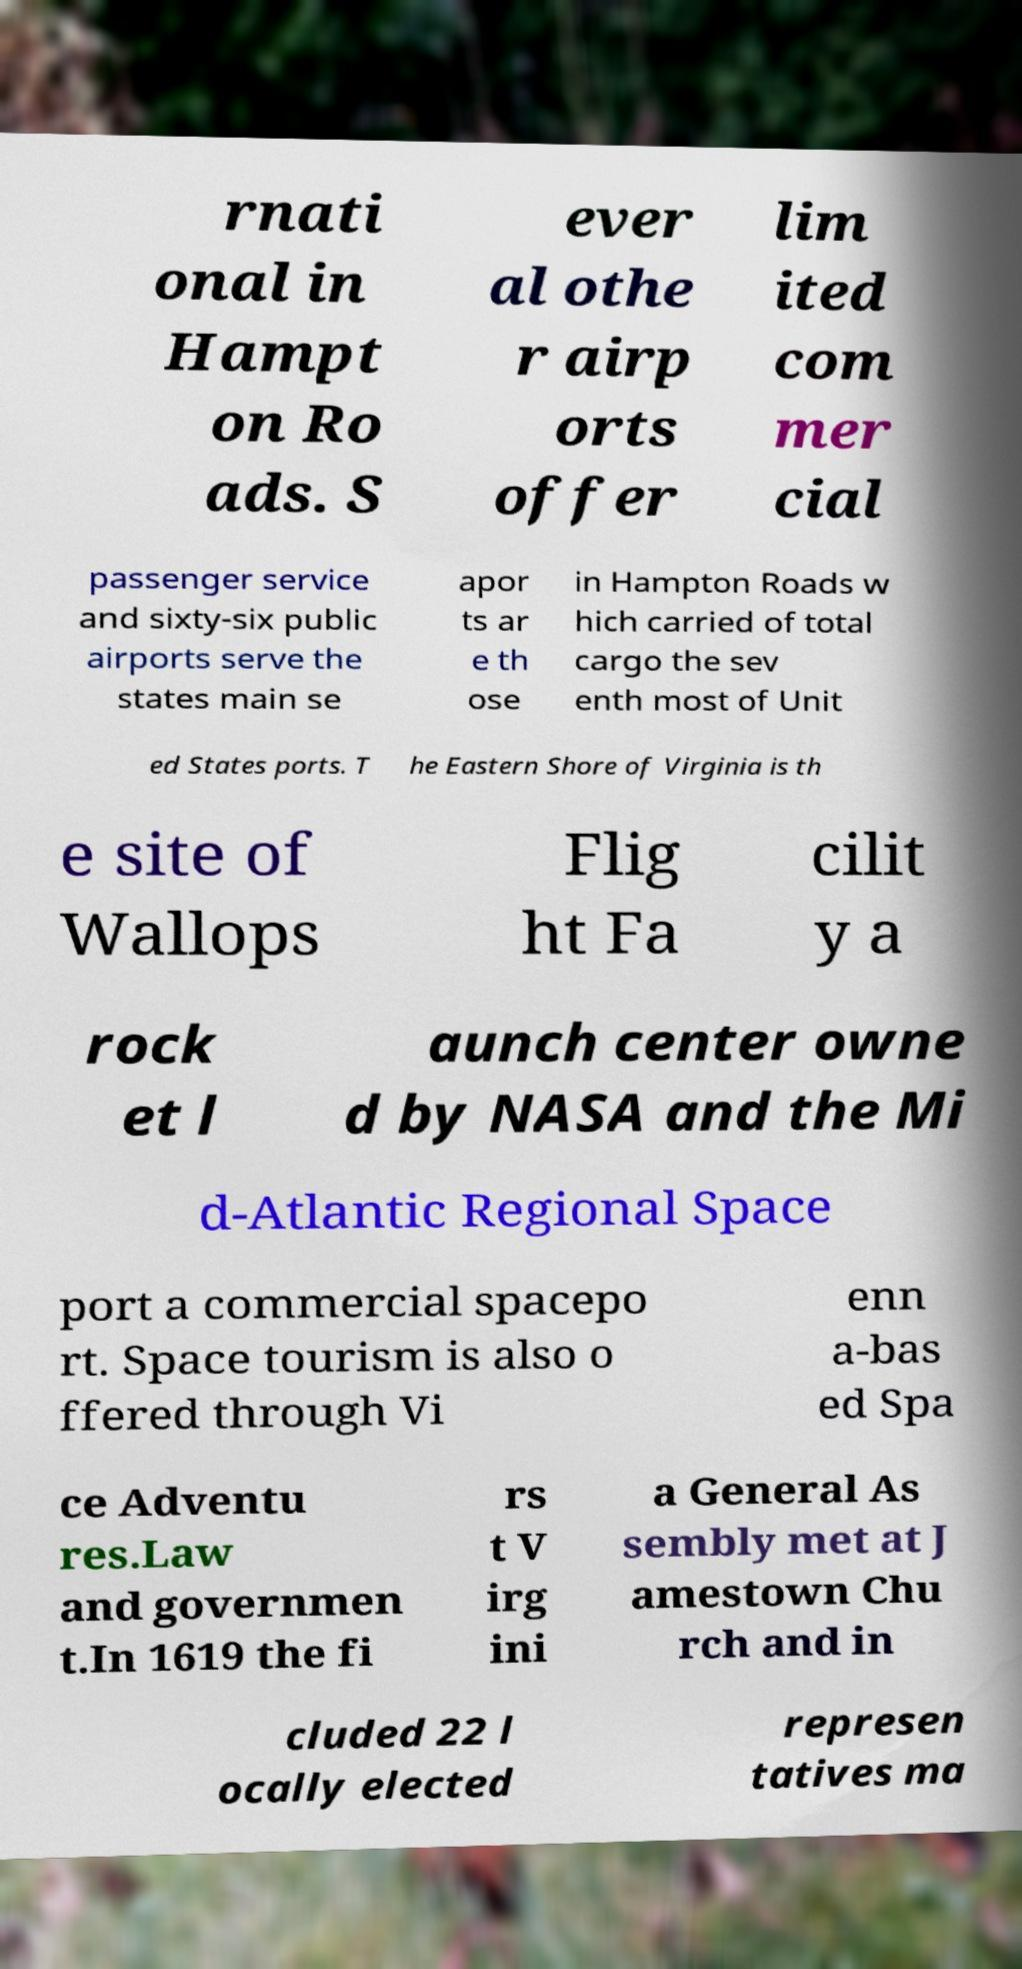Could you assist in decoding the text presented in this image and type it out clearly? rnati onal in Hampt on Ro ads. S ever al othe r airp orts offer lim ited com mer cial passenger service and sixty-six public airports serve the states main se apor ts ar e th ose in Hampton Roads w hich carried of total cargo the sev enth most of Unit ed States ports. T he Eastern Shore of Virginia is th e site of Wallops Flig ht Fa cilit y a rock et l aunch center owne d by NASA and the Mi d-Atlantic Regional Space port a commercial spacepo rt. Space tourism is also o ffered through Vi enn a-bas ed Spa ce Adventu res.Law and governmen t.In 1619 the fi rs t V irg ini a General As sembly met at J amestown Chu rch and in cluded 22 l ocally elected represen tatives ma 